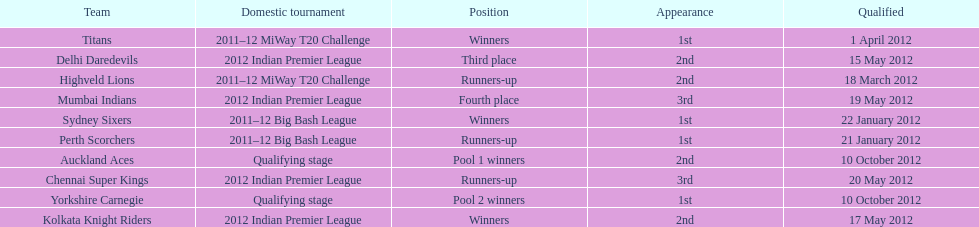Which team came in after the titans in the miway t20 challenge? Highveld Lions. 